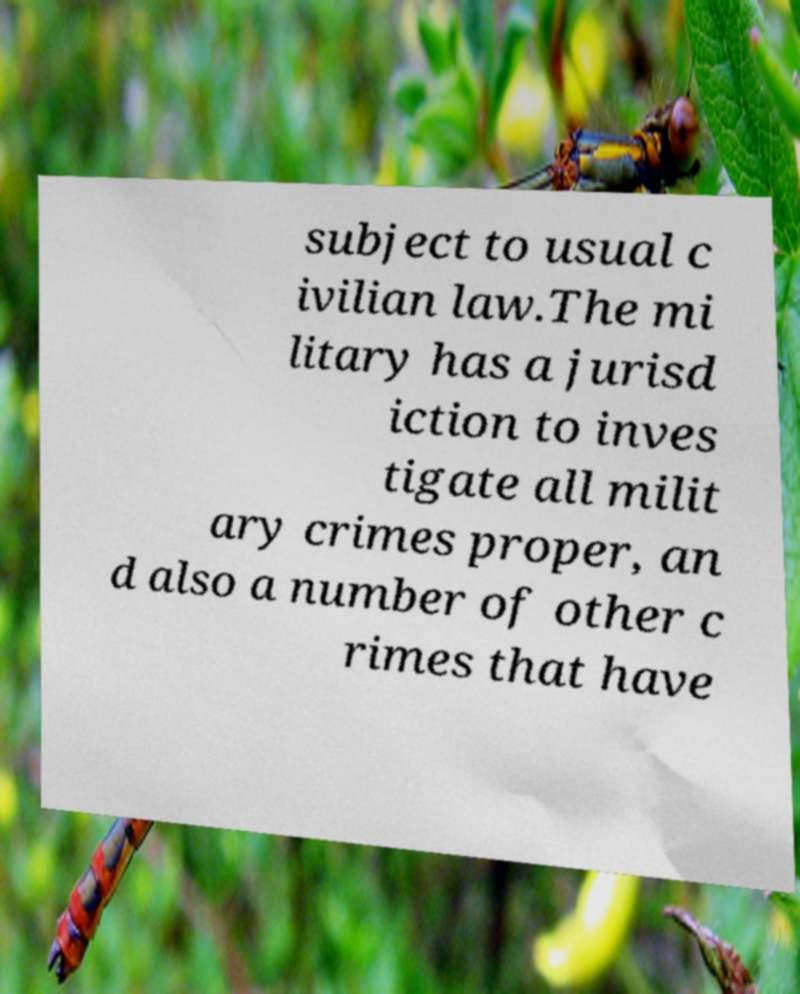Could you extract and type out the text from this image? subject to usual c ivilian law.The mi litary has a jurisd iction to inves tigate all milit ary crimes proper, an d also a number of other c rimes that have 